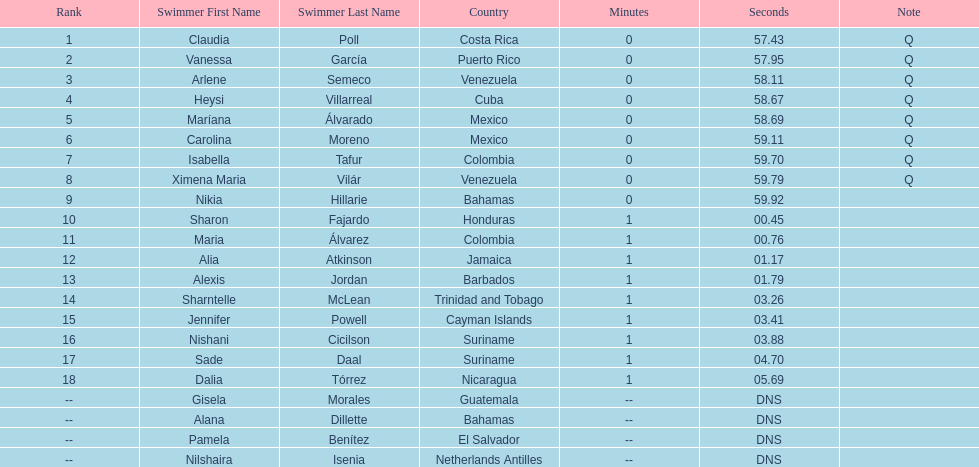What swimmer had the top or first rank? Claudia Poll. 